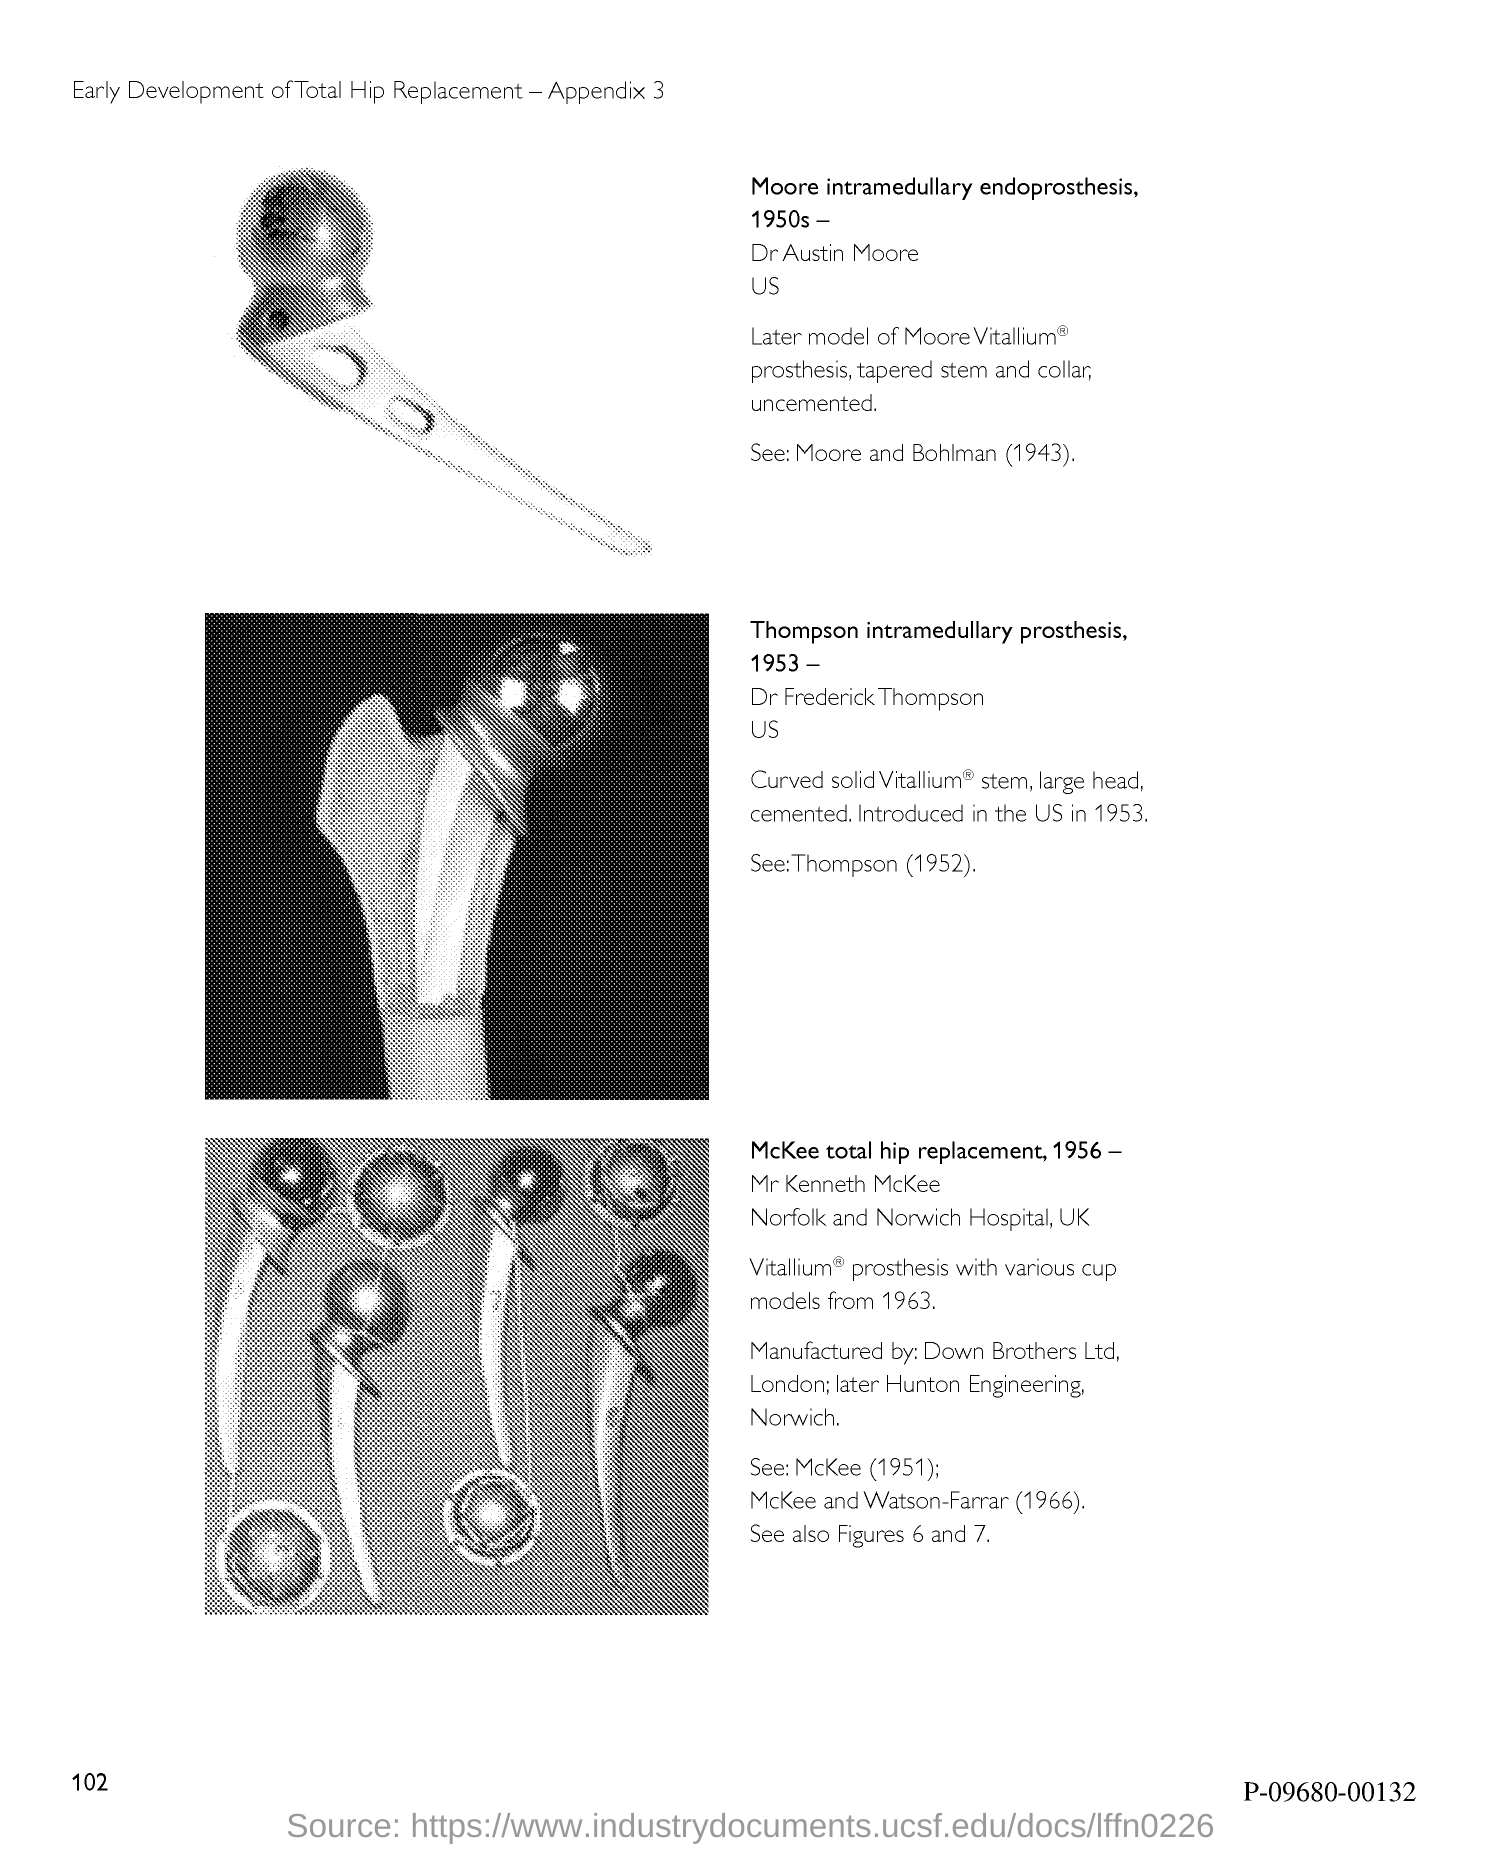What is the number at bottom-left corner of the page ?
Your response must be concise. 102. 